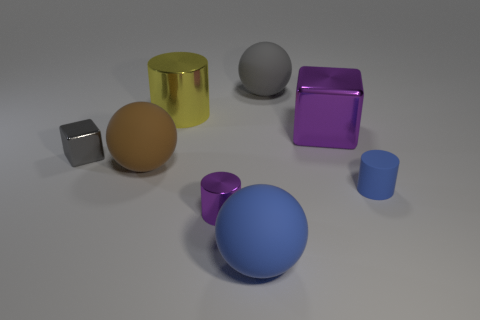What number of things are large spheres to the right of the brown matte sphere or blue rubber things in front of the small blue matte cylinder?
Your answer should be very brief. 2. What number of red things are rubber things or tiny metallic blocks?
Your answer should be very brief. 0. What is the material of the large ball that is behind the tiny purple shiny cylinder and right of the tiny shiny cylinder?
Keep it short and to the point. Rubber. Is the material of the big blue sphere the same as the large yellow cylinder?
Make the answer very short. No. How many other gray metal objects have the same size as the gray metal object?
Make the answer very short. 0. Are there the same number of large objects that are in front of the rubber cylinder and big gray things?
Your answer should be compact. Yes. How many things are right of the purple cylinder and behind the large cube?
Provide a succinct answer. 1. There is a tiny thing that is to the right of the tiny metallic cylinder; is it the same shape as the small purple metallic thing?
Give a very brief answer. Yes. What material is the purple object that is the same size as the rubber cylinder?
Your answer should be very brief. Metal. Are there the same number of shiny blocks in front of the big purple metallic block and yellow shiny objects that are in front of the tiny blue cylinder?
Keep it short and to the point. No. 